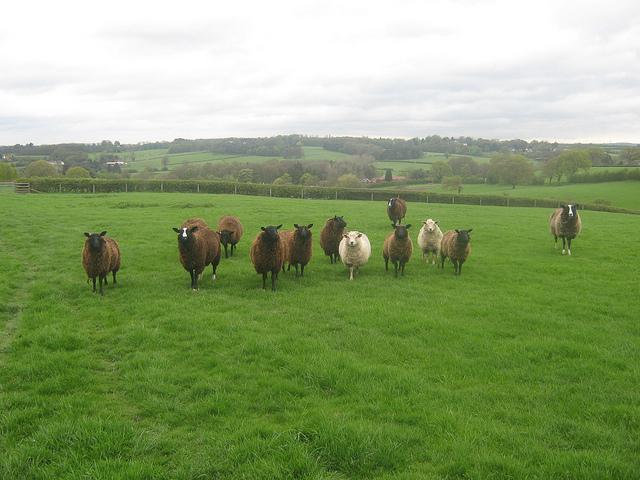How many of them are white?
Give a very brief answer. 2. 